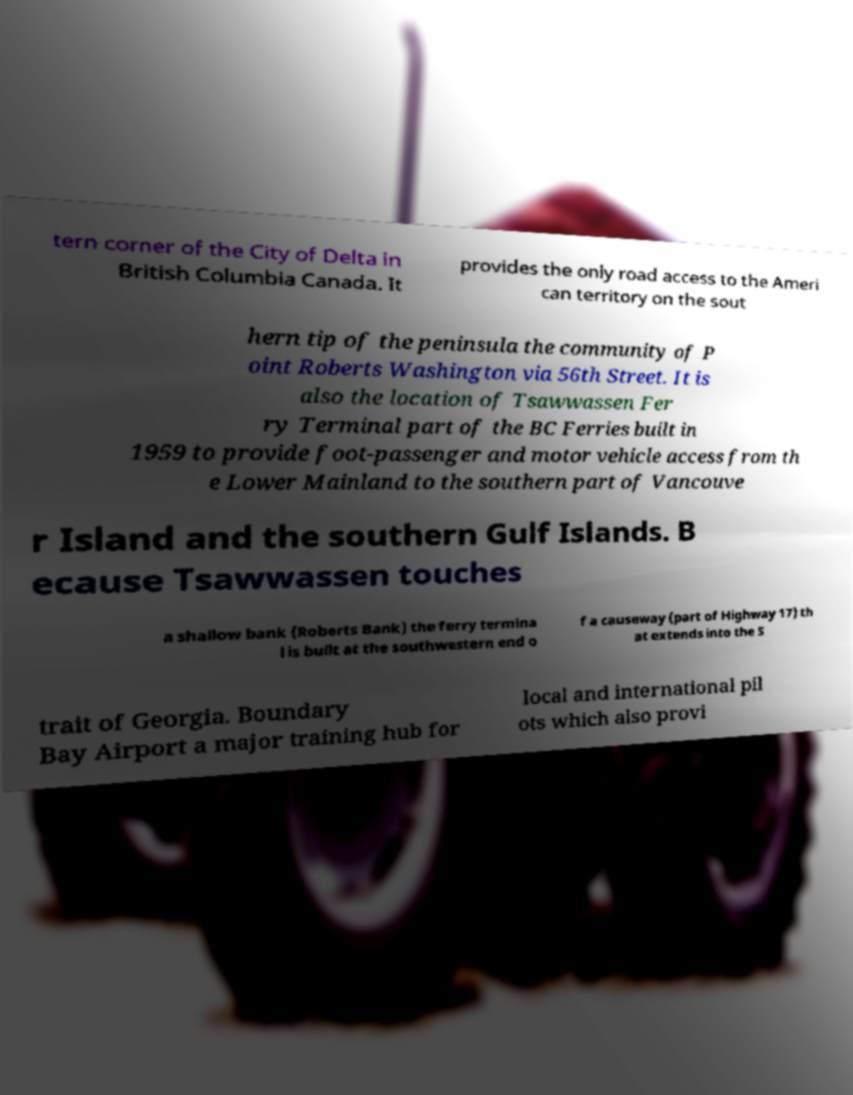I need the written content from this picture converted into text. Can you do that? tern corner of the City of Delta in British Columbia Canada. It provides the only road access to the Ameri can territory on the sout hern tip of the peninsula the community of P oint Roberts Washington via 56th Street. It is also the location of Tsawwassen Fer ry Terminal part of the BC Ferries built in 1959 to provide foot-passenger and motor vehicle access from th e Lower Mainland to the southern part of Vancouve r Island and the southern Gulf Islands. B ecause Tsawwassen touches a shallow bank (Roberts Bank) the ferry termina l is built at the southwestern end o f a causeway (part of Highway 17) th at extends into the S trait of Georgia. Boundary Bay Airport a major training hub for local and international pil ots which also provi 